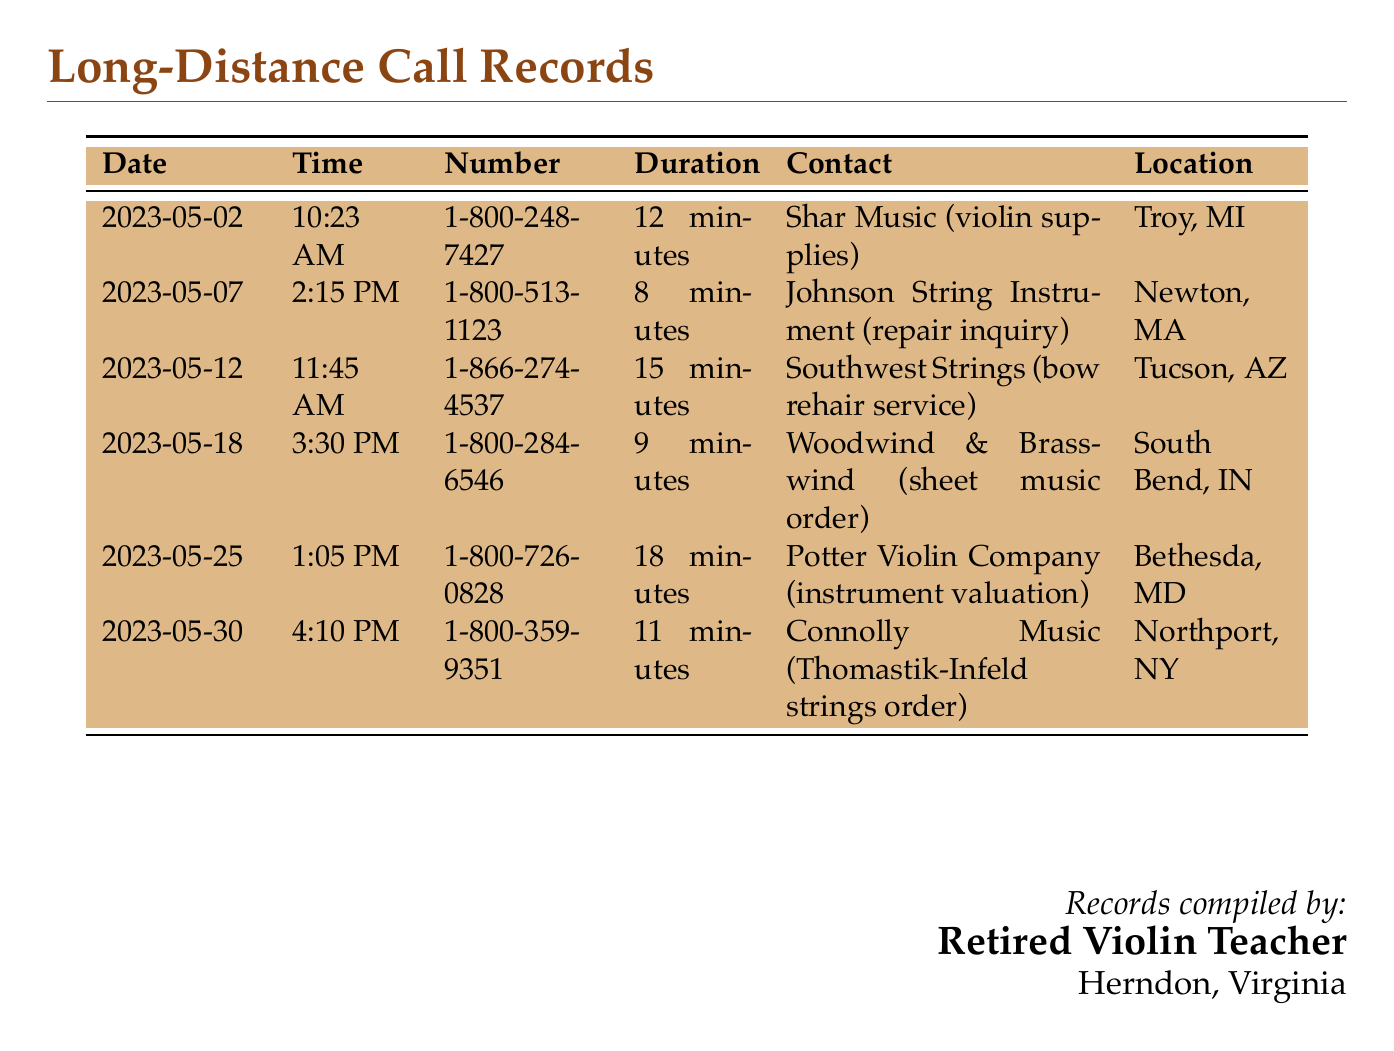what was the longest call duration? The longest call duration listed is the one with Potter Violin Company, lasting 18 minutes.
Answer: 18 minutes who did you contact on May 12th? On May 12th, the contact made was with Southwest Strings regarding a bow rehair service.
Answer: Southwest Strings how many calls were made to instrument suppliers? The document lists calls made to various instrument suppliers, totaling 6 calls.
Answer: 6 calls what is the location of Shar Music? Shar Music is located in Troy, Michigan.
Answer: Troy, MI which contact was in Northport, NY? The contact in Northport, NY is Connolly Music for the Thomastik-Infeld strings order.
Answer: Connolly Music what time did you call Johnson String Instrument? The call to Johnson String Instrument was made at 2:15 PM.
Answer: 2:15 PM which call was about instrument valuation? The call regarding instrument valuation was made to Potter Violin Company.
Answer: Potter Violin Company when was the call to Woodwind & Brasswind? The call to Woodwind & Brasswind occurred on May 18th.
Answer: May 18th 